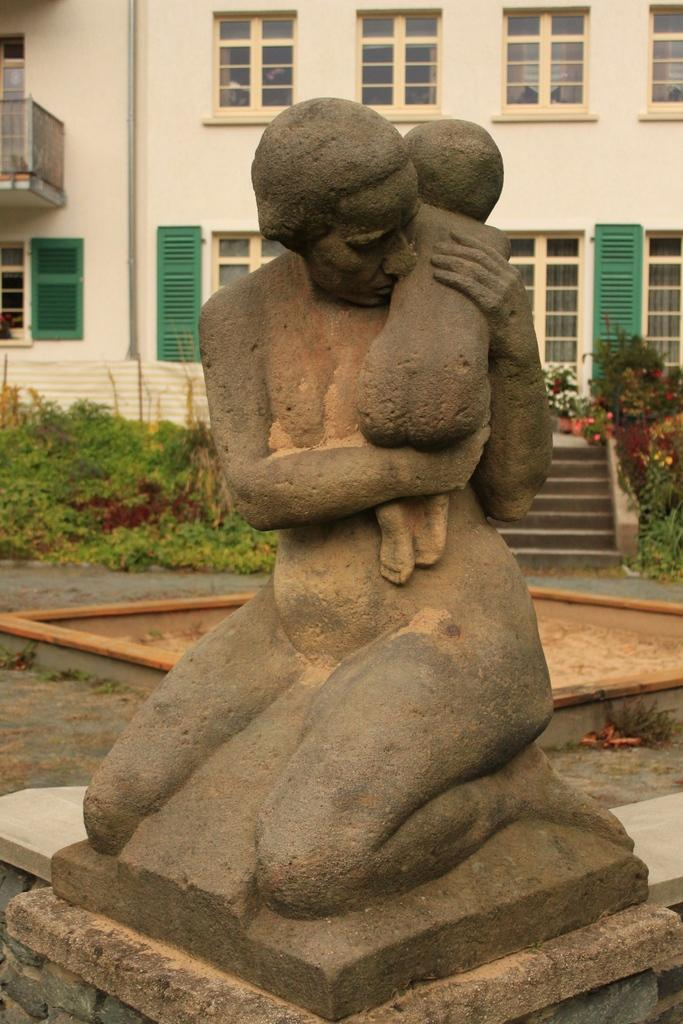What is the main subject of the image? There is a sculpture in the image. What can be seen behind the sculpture? There are plants behind the sculpture. What is visible in the background of the image? There is a building in the background of the image. How many apples are hanging from the line in the image? There is no line or apples present in the image. 